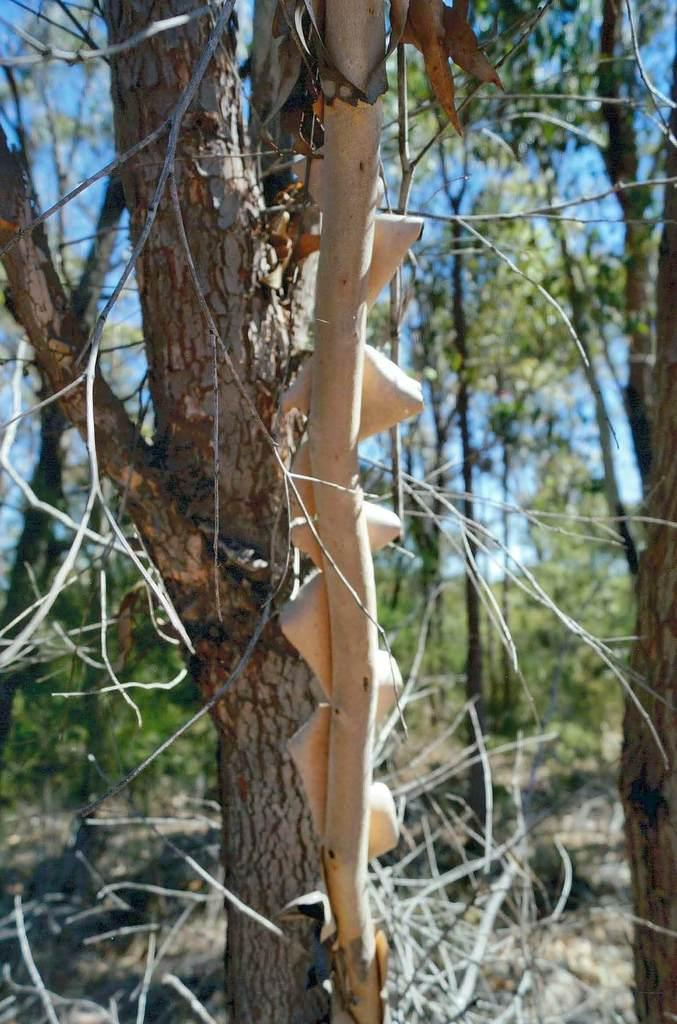What type of vegetation can be seen in the image? There are trees in the image. What colors are the trees in the image? The trees have brown and cream colors. Where are the trees located in the image? The trees are in the background of the image. What else can be seen in the background of the image? The sky is visible in the background of the image. What brand of toothpaste is advertised on the trees in the image? There is no toothpaste or advertisement present on the trees in the image; they are simply trees with brown and cream colors. 